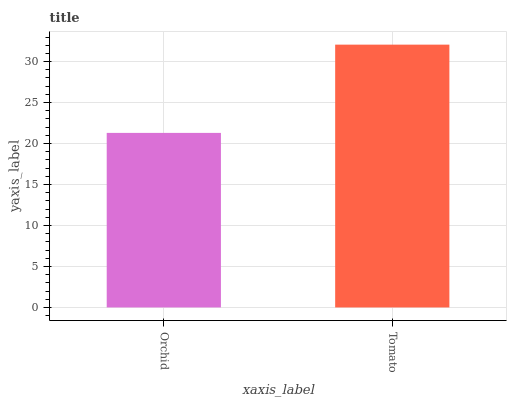Is Orchid the minimum?
Answer yes or no. Yes. Is Tomato the maximum?
Answer yes or no. Yes. Is Tomato the minimum?
Answer yes or no. No. Is Tomato greater than Orchid?
Answer yes or no. Yes. Is Orchid less than Tomato?
Answer yes or no. Yes. Is Orchid greater than Tomato?
Answer yes or no. No. Is Tomato less than Orchid?
Answer yes or no. No. Is Tomato the high median?
Answer yes or no. Yes. Is Orchid the low median?
Answer yes or no. Yes. Is Orchid the high median?
Answer yes or no. No. Is Tomato the low median?
Answer yes or no. No. 